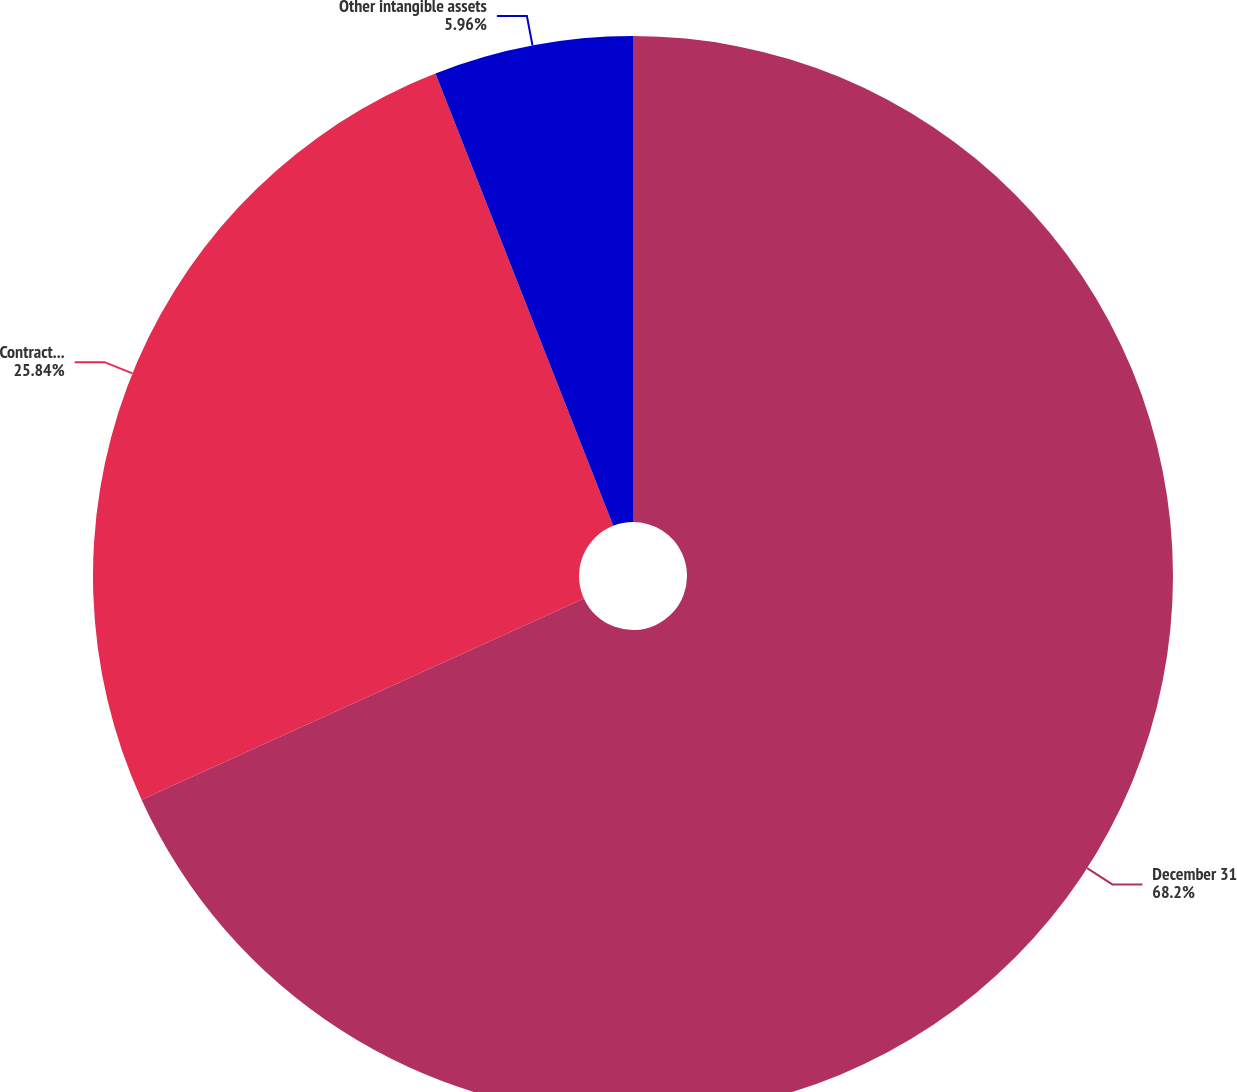Convert chart to OTSL. <chart><loc_0><loc_0><loc_500><loc_500><pie_chart><fcel>December 31<fcel>Contract and program<fcel>Other intangible assets<nl><fcel>68.2%<fcel>25.84%<fcel>5.96%<nl></chart> 